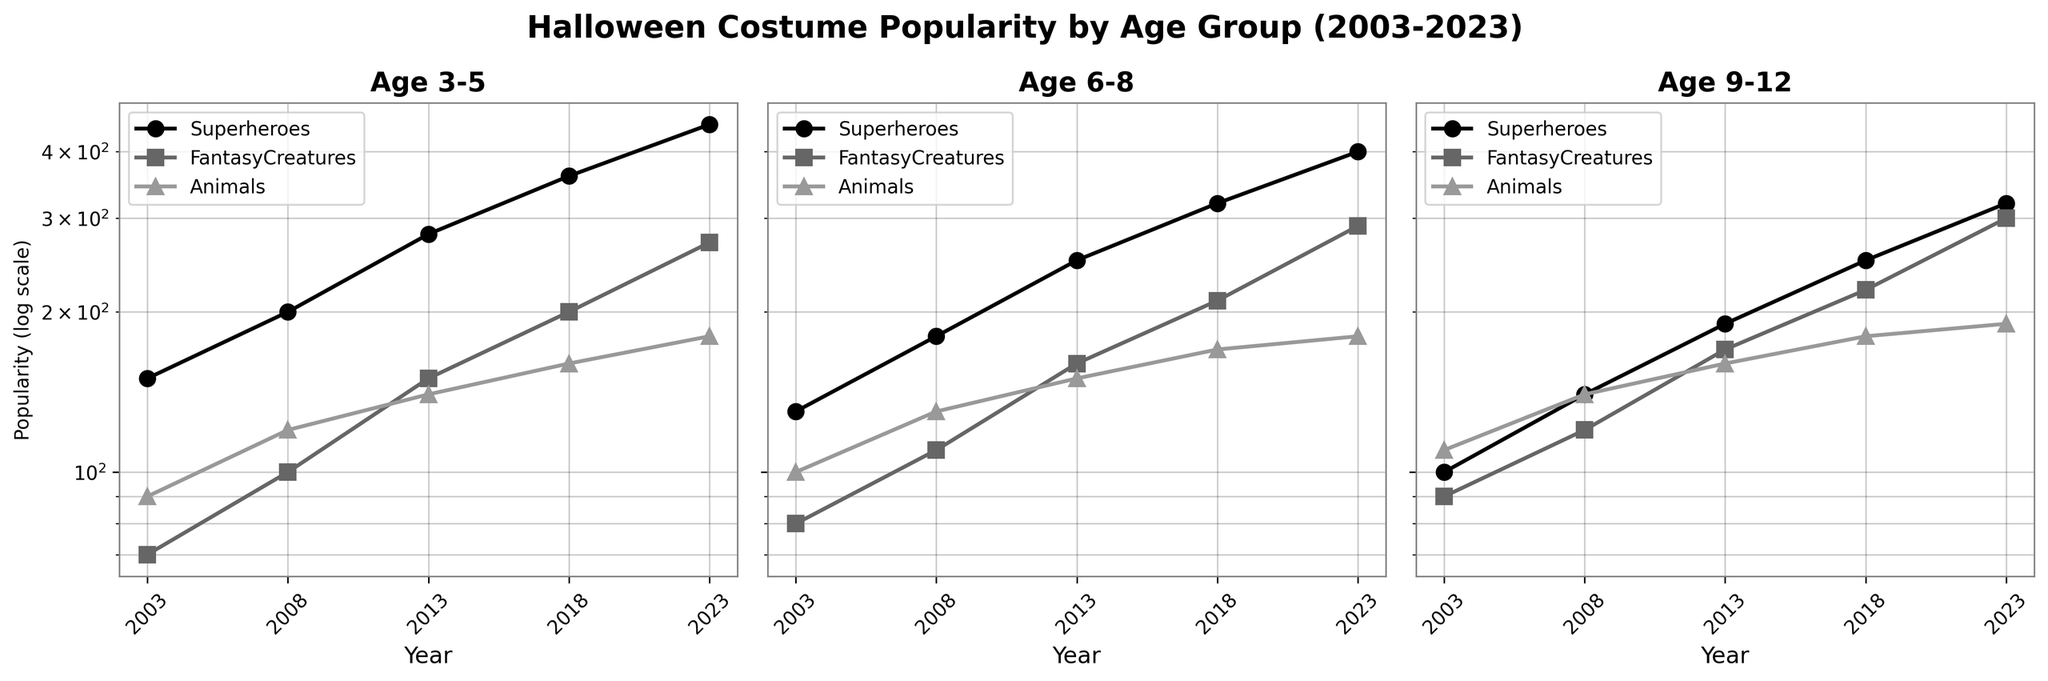What's the title of the figure? The title of the figure is displayed at the top in a bold and larger font. It summarizes the main subject of the plot.
Answer: Halloween Costume Popularity by Age Group (2003-2023) How many age groups are represented in the figure? By looking at the sub-titles of each subplot, we can see there are three different age groups mentioned.
Answer: 3 Which theme had the highest popularity among 3-5-year-olds in 2023? In the subplot for Age 3-5, the theme with the highest data point on the y-axis in 2023 corresponds to Superheroes.
Answer: Superheroes Which age group had the most significant increase in the popularity of Fantasy Creatures from 2003 to 2023? We need to compare the increase in the popularity of Fantasy Creatures across the three age group subplots from 2003 to 2023. Age 9-12 shows the largest increase.
Answer: 9-12 Between Superheroes and Animals, which theme shows a sharper increase in popularity for age group 6-8 from 2003 to 2023? By inspecting the subplot for age 6-8, we can observe the slope of the lines for Superheroes and Animals from 2003 to 2023. Superheroes exhibits a steeper slope.
Answer: Superheroes Across all age groups, which theme had the least growth in popularity from 2003 to 2023? By comparing the slopes of the lines for each theme across all subplots, we see that Animals had the smallest increase.
Answer: Animals In what year did the popularity of Superheroes surpass 200 for the first time in the age group 3-5? Looking at the subplot for Age 3-5, Superheroes crossed the 200 mark between 2003 and 2008. The exact year can be confirmed by checking 2008.
Answer: 2008 What was the popularity of Fantasy Creatures in the age group 9-12 in 2013? By looking at the subplot for Age 9-12, at the intersection of Fantasy Creatures and the year 2013, we find the popularity value.
Answer: 170 Compare the popularity of Animals in 2018 between age groups 3-5 and 6-8. By examining the subplots for Age 3-5 and Age 6-8, we see the points for Animals in 2018. Both age groups have the same popularity value for Animals in 2018.
Answer: Equal 